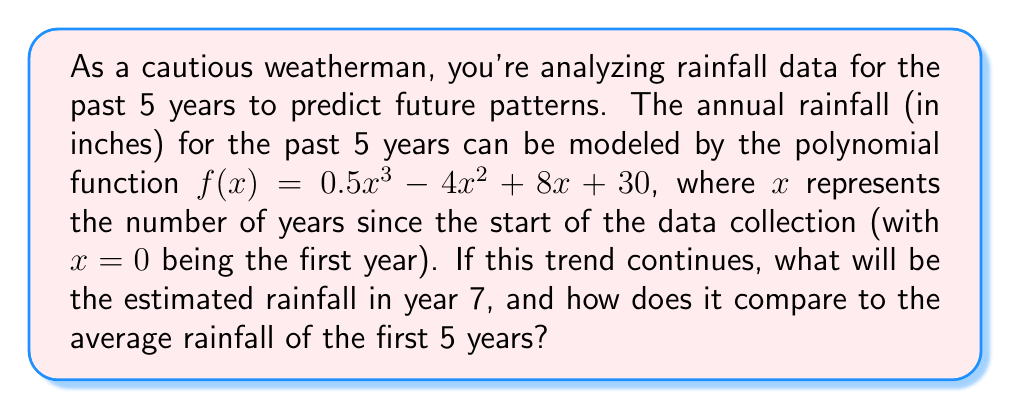Teach me how to tackle this problem. To solve this problem, we'll follow these steps:

1) First, let's calculate the rainfall for each of the first 5 years:

   Year 1 (x = 0): $f(0) = 0.5(0)^3 - 4(0)^2 + 8(0) + 30 = 30$ inches
   Year 2 (x = 1): $f(1) = 0.5(1)^3 - 4(1)^2 + 8(1) + 30 = 34.5$ inches
   Year 3 (x = 2): $f(2) = 0.5(2)^3 - 4(2)^2 + 8(2) + 30 = 34$ inches
   Year 4 (x = 3): $f(3) = 0.5(3)^3 - 4(3)^2 + 8(3) + 30 = 31.5$ inches
   Year 5 (x = 4): $f(4) = 0.5(4)^3 - 4(4)^2 + 8(4) + 30 = 30$ inches

2) Calculate the average rainfall for the first 5 years:
   $\text{Average} = \frac{30 + 34.5 + 34 + 31.5 + 30}{5} = 32$ inches

3) Estimate the rainfall for year 7 (x = 6):
   $f(6) = 0.5(6)^3 - 4(6)^2 + 8(6) + 30$
         $= 108 - 144 + 48 + 30$
         $= 42$ inches

4) Compare the year 7 estimate to the 5-year average:
   Difference = 42 - 32 = 10 inches

The estimated rainfall for year 7 is 10 inches more than the average of the first 5 years.
Answer: The estimated rainfall for year 7 is 42 inches, which is 10 inches more than the average rainfall of the first 5 years (32 inches). 